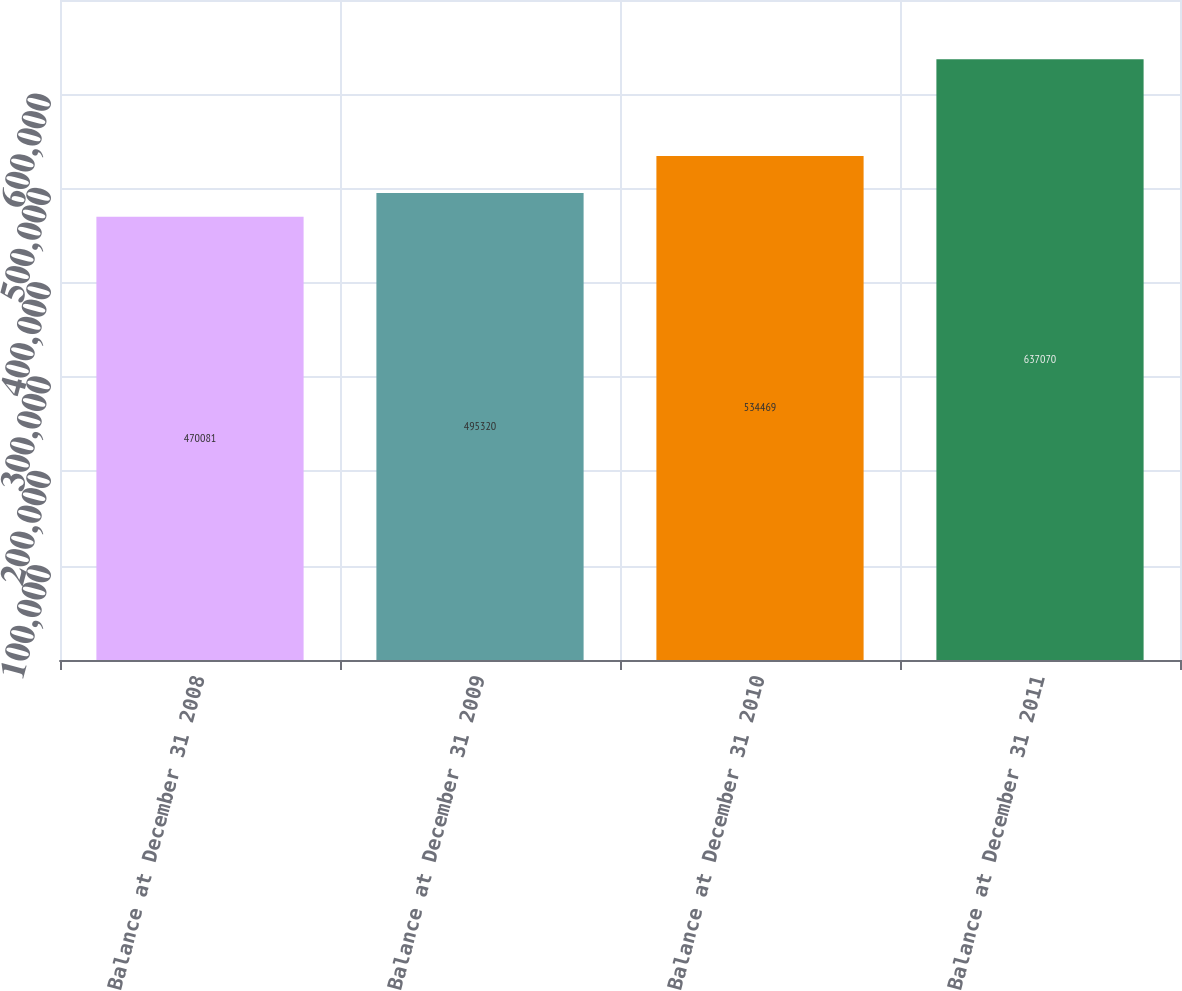<chart> <loc_0><loc_0><loc_500><loc_500><bar_chart><fcel>Balance at December 31 2008<fcel>Balance at December 31 2009<fcel>Balance at December 31 2010<fcel>Balance at December 31 2011<nl><fcel>470081<fcel>495320<fcel>534469<fcel>637070<nl></chart> 